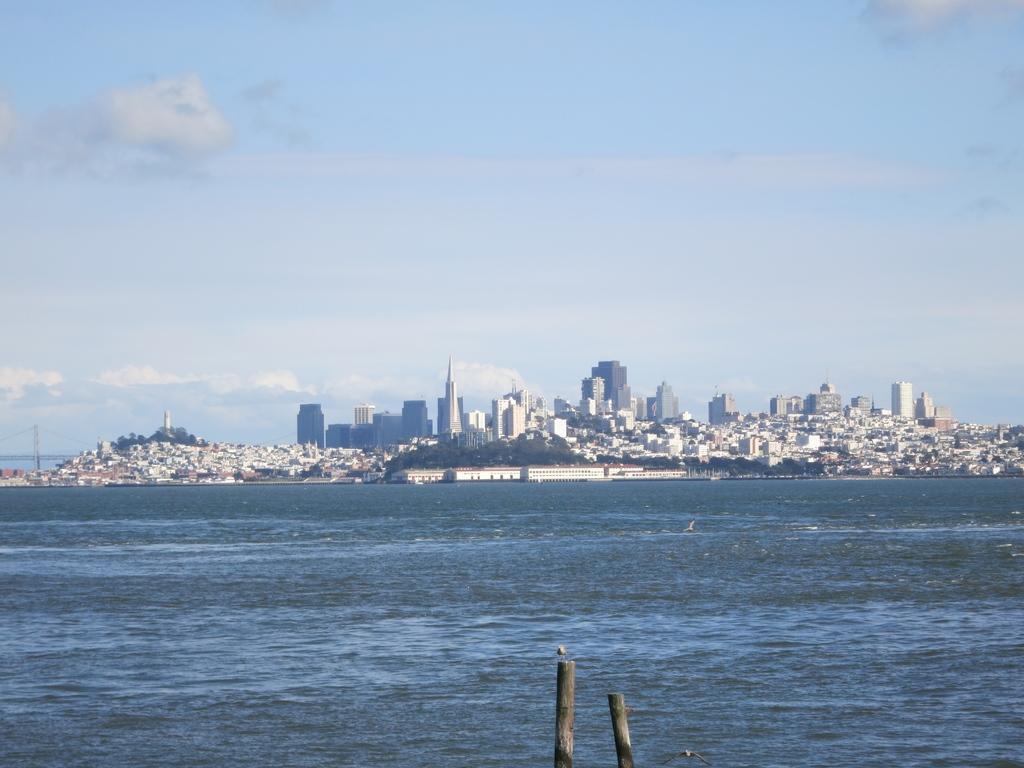Describe this image in one or two sentences. There is water of an ocean. In the background, there are buildings and trees on the ground and there are clouds in the blue sky. 